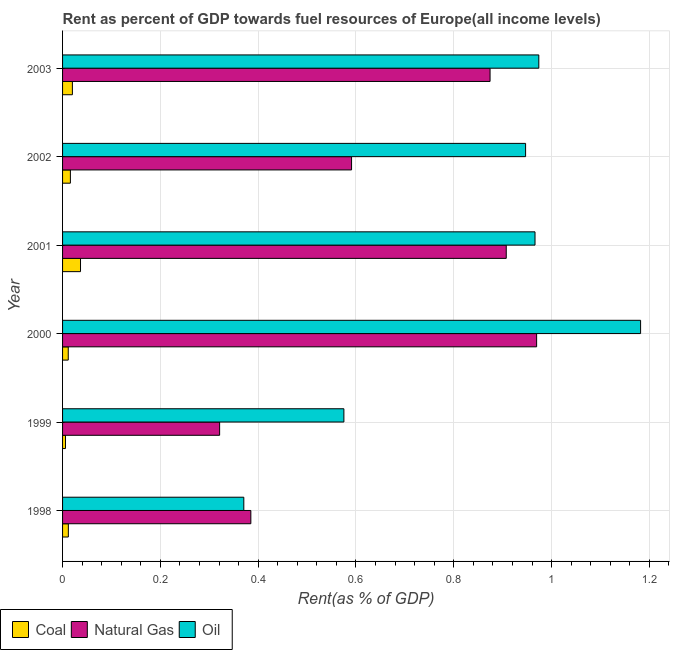How many different coloured bars are there?
Make the answer very short. 3. How many bars are there on the 4th tick from the bottom?
Offer a very short reply. 3. What is the rent towards oil in 2000?
Keep it short and to the point. 1.18. Across all years, what is the maximum rent towards oil?
Provide a succinct answer. 1.18. Across all years, what is the minimum rent towards oil?
Your answer should be compact. 0.37. In which year was the rent towards oil maximum?
Your answer should be very brief. 2000. What is the total rent towards natural gas in the graph?
Ensure brevity in your answer.  4.05. What is the difference between the rent towards natural gas in 2000 and that in 2002?
Provide a succinct answer. 0.38. What is the difference between the rent towards coal in 1999 and the rent towards natural gas in 2001?
Your response must be concise. -0.9. What is the average rent towards coal per year?
Offer a terse response. 0.02. In the year 2003, what is the difference between the rent towards natural gas and rent towards coal?
Your answer should be compact. 0.85. In how many years, is the rent towards coal greater than 0.32 %?
Your answer should be compact. 0. What is the ratio of the rent towards natural gas in 1999 to that in 2001?
Your response must be concise. 0.35. Is the rent towards oil in 1999 less than that in 2002?
Your response must be concise. Yes. Is the difference between the rent towards coal in 1999 and 2001 greater than the difference between the rent towards natural gas in 1999 and 2001?
Offer a very short reply. Yes. What is the difference between the highest and the second highest rent towards coal?
Your response must be concise. 0.02. What does the 2nd bar from the top in 1999 represents?
Offer a terse response. Natural Gas. What does the 1st bar from the bottom in 2001 represents?
Your answer should be very brief. Coal. Is it the case that in every year, the sum of the rent towards coal and rent towards natural gas is greater than the rent towards oil?
Provide a short and direct response. No. What is the difference between two consecutive major ticks on the X-axis?
Provide a short and direct response. 0.2. Are the values on the major ticks of X-axis written in scientific E-notation?
Your answer should be very brief. No. Does the graph contain grids?
Your response must be concise. Yes. What is the title of the graph?
Keep it short and to the point. Rent as percent of GDP towards fuel resources of Europe(all income levels). What is the label or title of the X-axis?
Provide a succinct answer. Rent(as % of GDP). What is the label or title of the Y-axis?
Your response must be concise. Year. What is the Rent(as % of GDP) of Coal in 1998?
Offer a terse response. 0.01. What is the Rent(as % of GDP) in Natural Gas in 1998?
Your response must be concise. 0.38. What is the Rent(as % of GDP) in Oil in 1998?
Keep it short and to the point. 0.37. What is the Rent(as % of GDP) of Coal in 1999?
Offer a very short reply. 0.01. What is the Rent(as % of GDP) in Natural Gas in 1999?
Offer a terse response. 0.32. What is the Rent(as % of GDP) in Oil in 1999?
Your response must be concise. 0.58. What is the Rent(as % of GDP) of Coal in 2000?
Offer a terse response. 0.01. What is the Rent(as % of GDP) in Natural Gas in 2000?
Offer a terse response. 0.97. What is the Rent(as % of GDP) in Oil in 2000?
Keep it short and to the point. 1.18. What is the Rent(as % of GDP) of Coal in 2001?
Your answer should be very brief. 0.04. What is the Rent(as % of GDP) of Natural Gas in 2001?
Provide a short and direct response. 0.91. What is the Rent(as % of GDP) in Oil in 2001?
Your response must be concise. 0.97. What is the Rent(as % of GDP) of Coal in 2002?
Provide a short and direct response. 0.02. What is the Rent(as % of GDP) of Natural Gas in 2002?
Make the answer very short. 0.59. What is the Rent(as % of GDP) of Oil in 2002?
Provide a succinct answer. 0.95. What is the Rent(as % of GDP) of Coal in 2003?
Provide a succinct answer. 0.02. What is the Rent(as % of GDP) in Natural Gas in 2003?
Your answer should be compact. 0.87. What is the Rent(as % of GDP) in Oil in 2003?
Ensure brevity in your answer.  0.97. Across all years, what is the maximum Rent(as % of GDP) in Coal?
Provide a short and direct response. 0.04. Across all years, what is the maximum Rent(as % of GDP) of Natural Gas?
Make the answer very short. 0.97. Across all years, what is the maximum Rent(as % of GDP) of Oil?
Keep it short and to the point. 1.18. Across all years, what is the minimum Rent(as % of GDP) in Coal?
Your response must be concise. 0.01. Across all years, what is the minimum Rent(as % of GDP) in Natural Gas?
Ensure brevity in your answer.  0.32. Across all years, what is the minimum Rent(as % of GDP) of Oil?
Your answer should be compact. 0.37. What is the total Rent(as % of GDP) in Coal in the graph?
Provide a succinct answer. 0.1. What is the total Rent(as % of GDP) of Natural Gas in the graph?
Your response must be concise. 4.05. What is the total Rent(as % of GDP) of Oil in the graph?
Ensure brevity in your answer.  5.01. What is the difference between the Rent(as % of GDP) in Coal in 1998 and that in 1999?
Your response must be concise. 0.01. What is the difference between the Rent(as % of GDP) of Natural Gas in 1998 and that in 1999?
Make the answer very short. 0.06. What is the difference between the Rent(as % of GDP) in Oil in 1998 and that in 1999?
Your response must be concise. -0.2. What is the difference between the Rent(as % of GDP) in Natural Gas in 1998 and that in 2000?
Provide a succinct answer. -0.58. What is the difference between the Rent(as % of GDP) in Oil in 1998 and that in 2000?
Provide a succinct answer. -0.81. What is the difference between the Rent(as % of GDP) of Coal in 1998 and that in 2001?
Ensure brevity in your answer.  -0.02. What is the difference between the Rent(as % of GDP) of Natural Gas in 1998 and that in 2001?
Provide a succinct answer. -0.52. What is the difference between the Rent(as % of GDP) of Oil in 1998 and that in 2001?
Your response must be concise. -0.6. What is the difference between the Rent(as % of GDP) in Coal in 1998 and that in 2002?
Keep it short and to the point. -0. What is the difference between the Rent(as % of GDP) of Natural Gas in 1998 and that in 2002?
Keep it short and to the point. -0.21. What is the difference between the Rent(as % of GDP) in Oil in 1998 and that in 2002?
Offer a very short reply. -0.58. What is the difference between the Rent(as % of GDP) in Coal in 1998 and that in 2003?
Offer a terse response. -0.01. What is the difference between the Rent(as % of GDP) of Natural Gas in 1998 and that in 2003?
Make the answer very short. -0.49. What is the difference between the Rent(as % of GDP) in Oil in 1998 and that in 2003?
Make the answer very short. -0.6. What is the difference between the Rent(as % of GDP) in Coal in 1999 and that in 2000?
Offer a very short reply. -0.01. What is the difference between the Rent(as % of GDP) in Natural Gas in 1999 and that in 2000?
Make the answer very short. -0.65. What is the difference between the Rent(as % of GDP) of Oil in 1999 and that in 2000?
Provide a short and direct response. -0.61. What is the difference between the Rent(as % of GDP) in Coal in 1999 and that in 2001?
Make the answer very short. -0.03. What is the difference between the Rent(as % of GDP) in Natural Gas in 1999 and that in 2001?
Your response must be concise. -0.59. What is the difference between the Rent(as % of GDP) of Oil in 1999 and that in 2001?
Your answer should be very brief. -0.39. What is the difference between the Rent(as % of GDP) in Coal in 1999 and that in 2002?
Ensure brevity in your answer.  -0.01. What is the difference between the Rent(as % of GDP) in Natural Gas in 1999 and that in 2002?
Provide a short and direct response. -0.27. What is the difference between the Rent(as % of GDP) in Oil in 1999 and that in 2002?
Give a very brief answer. -0.37. What is the difference between the Rent(as % of GDP) in Coal in 1999 and that in 2003?
Keep it short and to the point. -0.01. What is the difference between the Rent(as % of GDP) of Natural Gas in 1999 and that in 2003?
Your answer should be very brief. -0.55. What is the difference between the Rent(as % of GDP) of Oil in 1999 and that in 2003?
Your answer should be very brief. -0.4. What is the difference between the Rent(as % of GDP) in Coal in 2000 and that in 2001?
Offer a terse response. -0.03. What is the difference between the Rent(as % of GDP) of Natural Gas in 2000 and that in 2001?
Your answer should be compact. 0.06. What is the difference between the Rent(as % of GDP) of Oil in 2000 and that in 2001?
Your answer should be compact. 0.22. What is the difference between the Rent(as % of GDP) in Coal in 2000 and that in 2002?
Offer a terse response. -0. What is the difference between the Rent(as % of GDP) in Natural Gas in 2000 and that in 2002?
Your answer should be very brief. 0.38. What is the difference between the Rent(as % of GDP) of Oil in 2000 and that in 2002?
Keep it short and to the point. 0.24. What is the difference between the Rent(as % of GDP) of Coal in 2000 and that in 2003?
Offer a very short reply. -0.01. What is the difference between the Rent(as % of GDP) in Natural Gas in 2000 and that in 2003?
Offer a terse response. 0.1. What is the difference between the Rent(as % of GDP) of Oil in 2000 and that in 2003?
Provide a short and direct response. 0.21. What is the difference between the Rent(as % of GDP) of Coal in 2001 and that in 2002?
Provide a succinct answer. 0.02. What is the difference between the Rent(as % of GDP) in Natural Gas in 2001 and that in 2002?
Offer a terse response. 0.32. What is the difference between the Rent(as % of GDP) in Oil in 2001 and that in 2002?
Offer a very short reply. 0.02. What is the difference between the Rent(as % of GDP) in Coal in 2001 and that in 2003?
Provide a short and direct response. 0.02. What is the difference between the Rent(as % of GDP) of Natural Gas in 2001 and that in 2003?
Your response must be concise. 0.03. What is the difference between the Rent(as % of GDP) of Oil in 2001 and that in 2003?
Give a very brief answer. -0.01. What is the difference between the Rent(as % of GDP) of Coal in 2002 and that in 2003?
Provide a succinct answer. -0. What is the difference between the Rent(as % of GDP) of Natural Gas in 2002 and that in 2003?
Offer a terse response. -0.28. What is the difference between the Rent(as % of GDP) of Oil in 2002 and that in 2003?
Ensure brevity in your answer.  -0.03. What is the difference between the Rent(as % of GDP) of Coal in 1998 and the Rent(as % of GDP) of Natural Gas in 1999?
Your answer should be very brief. -0.31. What is the difference between the Rent(as % of GDP) of Coal in 1998 and the Rent(as % of GDP) of Oil in 1999?
Offer a very short reply. -0.56. What is the difference between the Rent(as % of GDP) of Natural Gas in 1998 and the Rent(as % of GDP) of Oil in 1999?
Provide a short and direct response. -0.19. What is the difference between the Rent(as % of GDP) in Coal in 1998 and the Rent(as % of GDP) in Natural Gas in 2000?
Your answer should be compact. -0.96. What is the difference between the Rent(as % of GDP) in Coal in 1998 and the Rent(as % of GDP) in Oil in 2000?
Keep it short and to the point. -1.17. What is the difference between the Rent(as % of GDP) in Natural Gas in 1998 and the Rent(as % of GDP) in Oil in 2000?
Offer a very short reply. -0.8. What is the difference between the Rent(as % of GDP) in Coal in 1998 and the Rent(as % of GDP) in Natural Gas in 2001?
Provide a short and direct response. -0.9. What is the difference between the Rent(as % of GDP) of Coal in 1998 and the Rent(as % of GDP) of Oil in 2001?
Keep it short and to the point. -0.95. What is the difference between the Rent(as % of GDP) of Natural Gas in 1998 and the Rent(as % of GDP) of Oil in 2001?
Your response must be concise. -0.58. What is the difference between the Rent(as % of GDP) of Coal in 1998 and the Rent(as % of GDP) of Natural Gas in 2002?
Your answer should be compact. -0.58. What is the difference between the Rent(as % of GDP) of Coal in 1998 and the Rent(as % of GDP) of Oil in 2002?
Make the answer very short. -0.94. What is the difference between the Rent(as % of GDP) in Natural Gas in 1998 and the Rent(as % of GDP) in Oil in 2002?
Ensure brevity in your answer.  -0.56. What is the difference between the Rent(as % of GDP) of Coal in 1998 and the Rent(as % of GDP) of Natural Gas in 2003?
Make the answer very short. -0.86. What is the difference between the Rent(as % of GDP) of Coal in 1998 and the Rent(as % of GDP) of Oil in 2003?
Offer a very short reply. -0.96. What is the difference between the Rent(as % of GDP) in Natural Gas in 1998 and the Rent(as % of GDP) in Oil in 2003?
Provide a succinct answer. -0.59. What is the difference between the Rent(as % of GDP) in Coal in 1999 and the Rent(as % of GDP) in Natural Gas in 2000?
Make the answer very short. -0.96. What is the difference between the Rent(as % of GDP) in Coal in 1999 and the Rent(as % of GDP) in Oil in 2000?
Offer a very short reply. -1.18. What is the difference between the Rent(as % of GDP) in Natural Gas in 1999 and the Rent(as % of GDP) in Oil in 2000?
Make the answer very short. -0.86. What is the difference between the Rent(as % of GDP) in Coal in 1999 and the Rent(as % of GDP) in Natural Gas in 2001?
Keep it short and to the point. -0.9. What is the difference between the Rent(as % of GDP) in Coal in 1999 and the Rent(as % of GDP) in Oil in 2001?
Provide a short and direct response. -0.96. What is the difference between the Rent(as % of GDP) of Natural Gas in 1999 and the Rent(as % of GDP) of Oil in 2001?
Provide a succinct answer. -0.64. What is the difference between the Rent(as % of GDP) of Coal in 1999 and the Rent(as % of GDP) of Natural Gas in 2002?
Keep it short and to the point. -0.58. What is the difference between the Rent(as % of GDP) in Coal in 1999 and the Rent(as % of GDP) in Oil in 2002?
Keep it short and to the point. -0.94. What is the difference between the Rent(as % of GDP) of Natural Gas in 1999 and the Rent(as % of GDP) of Oil in 2002?
Provide a short and direct response. -0.63. What is the difference between the Rent(as % of GDP) of Coal in 1999 and the Rent(as % of GDP) of Natural Gas in 2003?
Offer a very short reply. -0.87. What is the difference between the Rent(as % of GDP) of Coal in 1999 and the Rent(as % of GDP) of Oil in 2003?
Offer a very short reply. -0.97. What is the difference between the Rent(as % of GDP) in Natural Gas in 1999 and the Rent(as % of GDP) in Oil in 2003?
Your response must be concise. -0.65. What is the difference between the Rent(as % of GDP) in Coal in 2000 and the Rent(as % of GDP) in Natural Gas in 2001?
Provide a short and direct response. -0.9. What is the difference between the Rent(as % of GDP) of Coal in 2000 and the Rent(as % of GDP) of Oil in 2001?
Offer a very short reply. -0.95. What is the difference between the Rent(as % of GDP) in Natural Gas in 2000 and the Rent(as % of GDP) in Oil in 2001?
Provide a succinct answer. 0. What is the difference between the Rent(as % of GDP) of Coal in 2000 and the Rent(as % of GDP) of Natural Gas in 2002?
Your response must be concise. -0.58. What is the difference between the Rent(as % of GDP) of Coal in 2000 and the Rent(as % of GDP) of Oil in 2002?
Keep it short and to the point. -0.94. What is the difference between the Rent(as % of GDP) in Natural Gas in 2000 and the Rent(as % of GDP) in Oil in 2002?
Offer a very short reply. 0.02. What is the difference between the Rent(as % of GDP) in Coal in 2000 and the Rent(as % of GDP) in Natural Gas in 2003?
Your answer should be compact. -0.86. What is the difference between the Rent(as % of GDP) in Coal in 2000 and the Rent(as % of GDP) in Oil in 2003?
Your answer should be very brief. -0.96. What is the difference between the Rent(as % of GDP) in Natural Gas in 2000 and the Rent(as % of GDP) in Oil in 2003?
Offer a very short reply. -0. What is the difference between the Rent(as % of GDP) of Coal in 2001 and the Rent(as % of GDP) of Natural Gas in 2002?
Keep it short and to the point. -0.55. What is the difference between the Rent(as % of GDP) of Coal in 2001 and the Rent(as % of GDP) of Oil in 2002?
Offer a terse response. -0.91. What is the difference between the Rent(as % of GDP) of Natural Gas in 2001 and the Rent(as % of GDP) of Oil in 2002?
Make the answer very short. -0.04. What is the difference between the Rent(as % of GDP) of Coal in 2001 and the Rent(as % of GDP) of Natural Gas in 2003?
Ensure brevity in your answer.  -0.84. What is the difference between the Rent(as % of GDP) of Coal in 2001 and the Rent(as % of GDP) of Oil in 2003?
Make the answer very short. -0.94. What is the difference between the Rent(as % of GDP) in Natural Gas in 2001 and the Rent(as % of GDP) in Oil in 2003?
Offer a terse response. -0.07. What is the difference between the Rent(as % of GDP) in Coal in 2002 and the Rent(as % of GDP) in Natural Gas in 2003?
Your response must be concise. -0.86. What is the difference between the Rent(as % of GDP) in Coal in 2002 and the Rent(as % of GDP) in Oil in 2003?
Provide a succinct answer. -0.96. What is the difference between the Rent(as % of GDP) of Natural Gas in 2002 and the Rent(as % of GDP) of Oil in 2003?
Your response must be concise. -0.38. What is the average Rent(as % of GDP) in Coal per year?
Offer a very short reply. 0.02. What is the average Rent(as % of GDP) of Natural Gas per year?
Provide a succinct answer. 0.67. What is the average Rent(as % of GDP) in Oil per year?
Offer a very short reply. 0.84. In the year 1998, what is the difference between the Rent(as % of GDP) in Coal and Rent(as % of GDP) in Natural Gas?
Your answer should be compact. -0.37. In the year 1998, what is the difference between the Rent(as % of GDP) of Coal and Rent(as % of GDP) of Oil?
Offer a terse response. -0.36. In the year 1998, what is the difference between the Rent(as % of GDP) of Natural Gas and Rent(as % of GDP) of Oil?
Your answer should be compact. 0.01. In the year 1999, what is the difference between the Rent(as % of GDP) in Coal and Rent(as % of GDP) in Natural Gas?
Your response must be concise. -0.32. In the year 1999, what is the difference between the Rent(as % of GDP) in Coal and Rent(as % of GDP) in Oil?
Offer a terse response. -0.57. In the year 1999, what is the difference between the Rent(as % of GDP) of Natural Gas and Rent(as % of GDP) of Oil?
Ensure brevity in your answer.  -0.25. In the year 2000, what is the difference between the Rent(as % of GDP) of Coal and Rent(as % of GDP) of Natural Gas?
Your response must be concise. -0.96. In the year 2000, what is the difference between the Rent(as % of GDP) in Coal and Rent(as % of GDP) in Oil?
Your response must be concise. -1.17. In the year 2000, what is the difference between the Rent(as % of GDP) in Natural Gas and Rent(as % of GDP) in Oil?
Offer a terse response. -0.21. In the year 2001, what is the difference between the Rent(as % of GDP) of Coal and Rent(as % of GDP) of Natural Gas?
Offer a terse response. -0.87. In the year 2001, what is the difference between the Rent(as % of GDP) in Coal and Rent(as % of GDP) in Oil?
Offer a terse response. -0.93. In the year 2001, what is the difference between the Rent(as % of GDP) of Natural Gas and Rent(as % of GDP) of Oil?
Make the answer very short. -0.06. In the year 2002, what is the difference between the Rent(as % of GDP) in Coal and Rent(as % of GDP) in Natural Gas?
Offer a very short reply. -0.57. In the year 2002, what is the difference between the Rent(as % of GDP) of Coal and Rent(as % of GDP) of Oil?
Keep it short and to the point. -0.93. In the year 2002, what is the difference between the Rent(as % of GDP) in Natural Gas and Rent(as % of GDP) in Oil?
Provide a short and direct response. -0.36. In the year 2003, what is the difference between the Rent(as % of GDP) in Coal and Rent(as % of GDP) in Natural Gas?
Keep it short and to the point. -0.85. In the year 2003, what is the difference between the Rent(as % of GDP) in Coal and Rent(as % of GDP) in Oil?
Give a very brief answer. -0.95. In the year 2003, what is the difference between the Rent(as % of GDP) in Natural Gas and Rent(as % of GDP) in Oil?
Ensure brevity in your answer.  -0.1. What is the ratio of the Rent(as % of GDP) of Coal in 1998 to that in 1999?
Ensure brevity in your answer.  1.97. What is the ratio of the Rent(as % of GDP) of Natural Gas in 1998 to that in 1999?
Offer a terse response. 1.2. What is the ratio of the Rent(as % of GDP) in Oil in 1998 to that in 1999?
Your response must be concise. 0.64. What is the ratio of the Rent(as % of GDP) in Coal in 1998 to that in 2000?
Make the answer very short. 1.02. What is the ratio of the Rent(as % of GDP) of Natural Gas in 1998 to that in 2000?
Offer a very short reply. 0.4. What is the ratio of the Rent(as % of GDP) of Oil in 1998 to that in 2000?
Provide a short and direct response. 0.31. What is the ratio of the Rent(as % of GDP) in Coal in 1998 to that in 2001?
Make the answer very short. 0.32. What is the ratio of the Rent(as % of GDP) of Natural Gas in 1998 to that in 2001?
Your answer should be very brief. 0.42. What is the ratio of the Rent(as % of GDP) in Oil in 1998 to that in 2001?
Give a very brief answer. 0.38. What is the ratio of the Rent(as % of GDP) in Coal in 1998 to that in 2002?
Provide a short and direct response. 0.74. What is the ratio of the Rent(as % of GDP) of Natural Gas in 1998 to that in 2002?
Make the answer very short. 0.65. What is the ratio of the Rent(as % of GDP) of Oil in 1998 to that in 2002?
Keep it short and to the point. 0.39. What is the ratio of the Rent(as % of GDP) in Coal in 1998 to that in 2003?
Make the answer very short. 0.59. What is the ratio of the Rent(as % of GDP) in Natural Gas in 1998 to that in 2003?
Offer a very short reply. 0.44. What is the ratio of the Rent(as % of GDP) in Oil in 1998 to that in 2003?
Provide a succinct answer. 0.38. What is the ratio of the Rent(as % of GDP) in Coal in 1999 to that in 2000?
Provide a short and direct response. 0.52. What is the ratio of the Rent(as % of GDP) of Natural Gas in 1999 to that in 2000?
Provide a succinct answer. 0.33. What is the ratio of the Rent(as % of GDP) of Oil in 1999 to that in 2000?
Your answer should be very brief. 0.49. What is the ratio of the Rent(as % of GDP) in Coal in 1999 to that in 2001?
Your answer should be compact. 0.16. What is the ratio of the Rent(as % of GDP) in Natural Gas in 1999 to that in 2001?
Your response must be concise. 0.35. What is the ratio of the Rent(as % of GDP) of Oil in 1999 to that in 2001?
Your response must be concise. 0.6. What is the ratio of the Rent(as % of GDP) in Coal in 1999 to that in 2002?
Provide a succinct answer. 0.37. What is the ratio of the Rent(as % of GDP) of Natural Gas in 1999 to that in 2002?
Keep it short and to the point. 0.54. What is the ratio of the Rent(as % of GDP) of Oil in 1999 to that in 2002?
Provide a short and direct response. 0.61. What is the ratio of the Rent(as % of GDP) of Coal in 1999 to that in 2003?
Keep it short and to the point. 0.3. What is the ratio of the Rent(as % of GDP) of Natural Gas in 1999 to that in 2003?
Provide a short and direct response. 0.37. What is the ratio of the Rent(as % of GDP) of Oil in 1999 to that in 2003?
Your response must be concise. 0.59. What is the ratio of the Rent(as % of GDP) of Coal in 2000 to that in 2001?
Offer a terse response. 0.32. What is the ratio of the Rent(as % of GDP) in Natural Gas in 2000 to that in 2001?
Ensure brevity in your answer.  1.07. What is the ratio of the Rent(as % of GDP) of Oil in 2000 to that in 2001?
Provide a succinct answer. 1.22. What is the ratio of the Rent(as % of GDP) in Coal in 2000 to that in 2002?
Offer a very short reply. 0.73. What is the ratio of the Rent(as % of GDP) of Natural Gas in 2000 to that in 2002?
Give a very brief answer. 1.64. What is the ratio of the Rent(as % of GDP) in Oil in 2000 to that in 2002?
Your response must be concise. 1.25. What is the ratio of the Rent(as % of GDP) in Coal in 2000 to that in 2003?
Keep it short and to the point. 0.58. What is the ratio of the Rent(as % of GDP) of Natural Gas in 2000 to that in 2003?
Keep it short and to the point. 1.11. What is the ratio of the Rent(as % of GDP) of Oil in 2000 to that in 2003?
Provide a succinct answer. 1.21. What is the ratio of the Rent(as % of GDP) in Coal in 2001 to that in 2002?
Offer a very short reply. 2.3. What is the ratio of the Rent(as % of GDP) of Natural Gas in 2001 to that in 2002?
Offer a very short reply. 1.54. What is the ratio of the Rent(as % of GDP) in Oil in 2001 to that in 2002?
Ensure brevity in your answer.  1.02. What is the ratio of the Rent(as % of GDP) of Coal in 2001 to that in 2003?
Your answer should be compact. 1.83. What is the ratio of the Rent(as % of GDP) in Natural Gas in 2001 to that in 2003?
Your answer should be very brief. 1.04. What is the ratio of the Rent(as % of GDP) in Oil in 2001 to that in 2003?
Your answer should be compact. 0.99. What is the ratio of the Rent(as % of GDP) in Coal in 2002 to that in 2003?
Provide a short and direct response. 0.8. What is the ratio of the Rent(as % of GDP) of Natural Gas in 2002 to that in 2003?
Provide a succinct answer. 0.68. What is the ratio of the Rent(as % of GDP) in Oil in 2002 to that in 2003?
Provide a short and direct response. 0.97. What is the difference between the highest and the second highest Rent(as % of GDP) in Coal?
Make the answer very short. 0.02. What is the difference between the highest and the second highest Rent(as % of GDP) of Natural Gas?
Your response must be concise. 0.06. What is the difference between the highest and the second highest Rent(as % of GDP) in Oil?
Provide a short and direct response. 0.21. What is the difference between the highest and the lowest Rent(as % of GDP) of Coal?
Your answer should be compact. 0.03. What is the difference between the highest and the lowest Rent(as % of GDP) of Natural Gas?
Your answer should be compact. 0.65. What is the difference between the highest and the lowest Rent(as % of GDP) in Oil?
Your answer should be very brief. 0.81. 